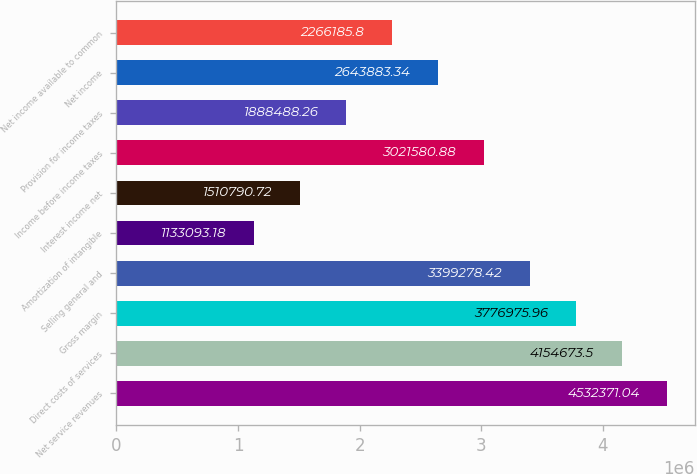Convert chart. <chart><loc_0><loc_0><loc_500><loc_500><bar_chart><fcel>Net service revenues<fcel>Direct costs of services<fcel>Gross margin<fcel>Selling general and<fcel>Amortization of intangible<fcel>Interest income net<fcel>Income before income taxes<fcel>Provision for income taxes<fcel>Net income<fcel>Net income available to common<nl><fcel>4.53237e+06<fcel>4.15467e+06<fcel>3.77698e+06<fcel>3.39928e+06<fcel>1.13309e+06<fcel>1.51079e+06<fcel>3.02158e+06<fcel>1.88849e+06<fcel>2.64388e+06<fcel>2.26619e+06<nl></chart> 